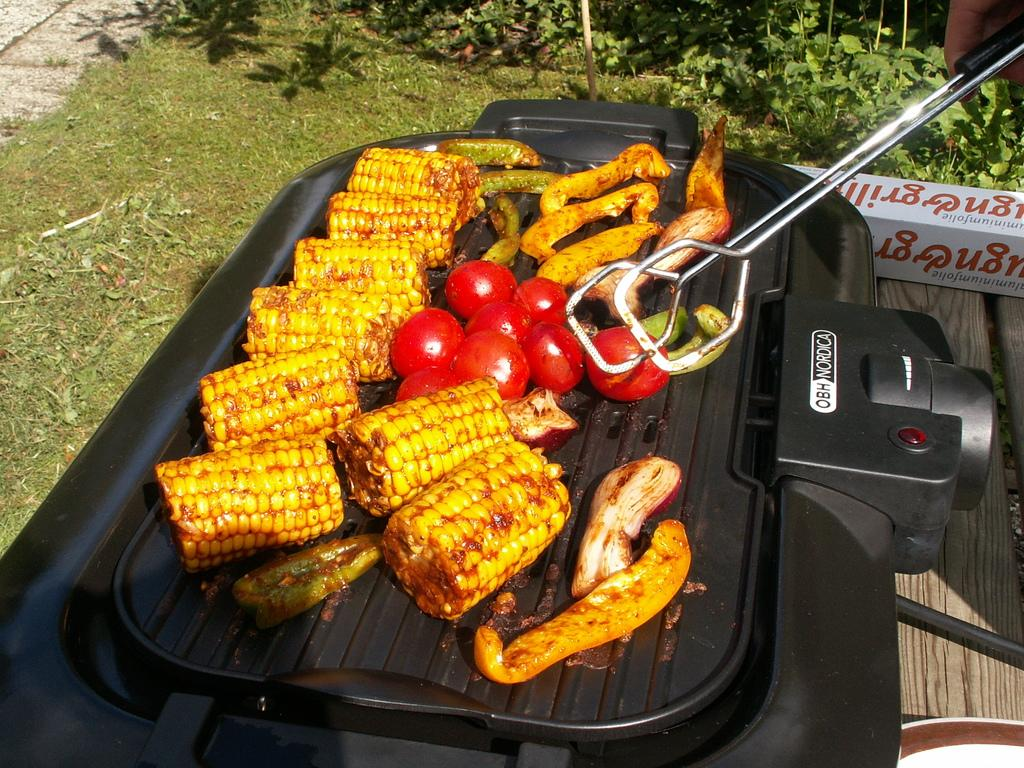<image>
Offer a succinct explanation of the picture presented. Someone is cooking vegetables on a OBH Nordica grill. 